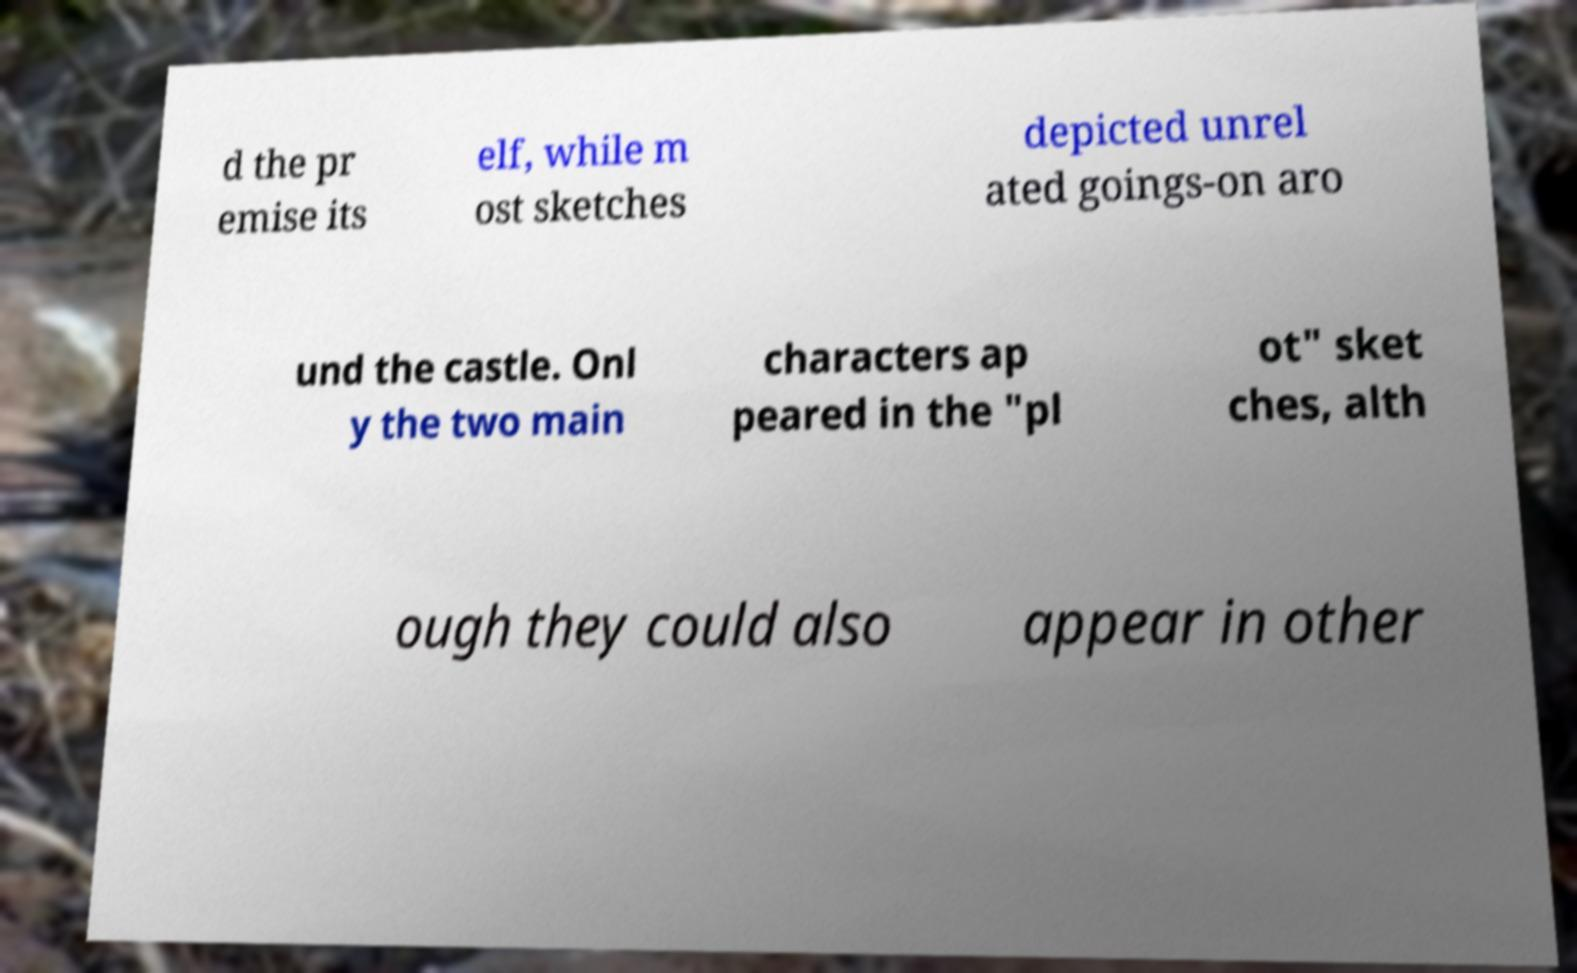Can you accurately transcribe the text from the provided image for me? d the pr emise its elf, while m ost sketches depicted unrel ated goings-on aro und the castle. Onl y the two main characters ap peared in the "pl ot" sket ches, alth ough they could also appear in other 